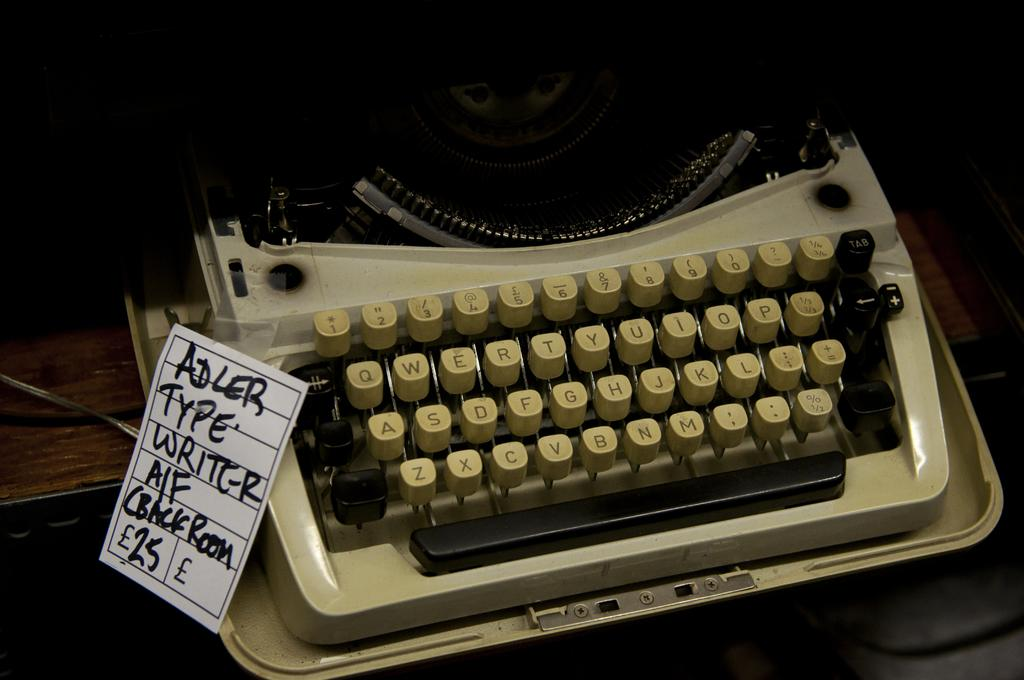<image>
Offer a succinct explanation of the picture presented. An old typewrite with a tag on it that says Adler Typewriter on it. 